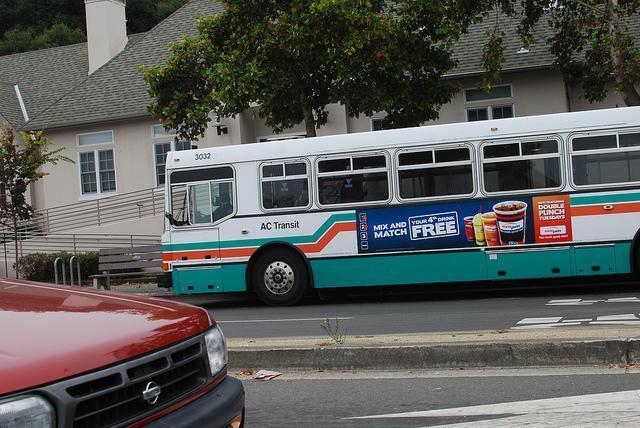Is the statement "The bus is facing the truck." accurate regarding the image?
Answer yes or no. No. 